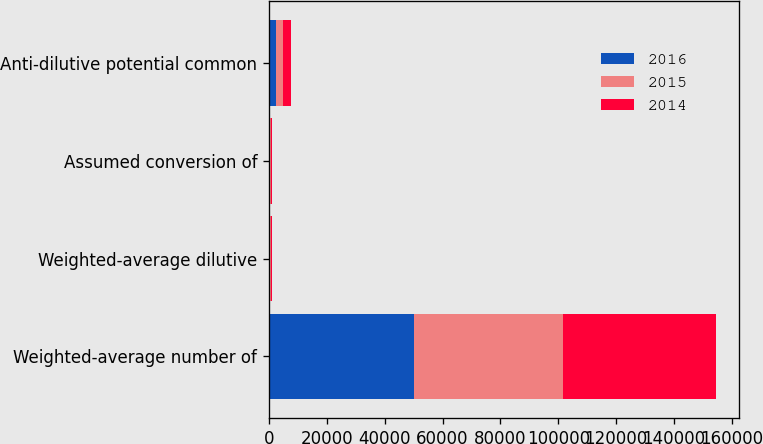Convert chart to OTSL. <chart><loc_0><loc_0><loc_500><loc_500><stacked_bar_chart><ecel><fcel>Weighted-average number of<fcel>Weighted-average dilutive<fcel>Assumed conversion of<fcel>Anti-dilutive potential common<nl><fcel>2016<fcel>50063<fcel>238<fcel>334<fcel>2443<nl><fcel>2015<fcel>51593<fcel>395<fcel>258<fcel>2563<nl><fcel>2014<fcel>53023<fcel>340<fcel>382<fcel>2574<nl></chart> 